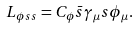Convert formula to latex. <formula><loc_0><loc_0><loc_500><loc_500>L _ { \phi s s } = C _ { \phi } \bar { s } \gamma _ { \mu } s \phi _ { \mu } .</formula> 